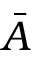Convert formula to latex. <formula><loc_0><loc_0><loc_500><loc_500>\bar { A }</formula> 